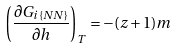<formula> <loc_0><loc_0><loc_500><loc_500>\left ( \frac { \partial G _ { i \{ N N \} } } { \partial h } \right ) _ { T } = - ( z + 1 ) m</formula> 